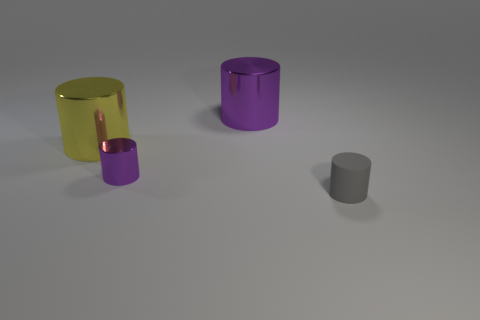Are there any purple shiny cylinders that have the same size as the yellow object?
Give a very brief answer. Yes. What size is the gray rubber thing?
Provide a succinct answer. Small. Are there an equal number of tiny matte cylinders that are behind the rubber cylinder and purple cylinders?
Your answer should be compact. No. How many other things are there of the same color as the matte thing?
Your response must be concise. 0. What color is the cylinder that is both behind the small purple cylinder and right of the big yellow metallic cylinder?
Provide a short and direct response. Purple. There is a metal cylinder that is behind the large metal cylinder in front of the large shiny object behind the yellow metallic object; how big is it?
Make the answer very short. Large. How many things are objects left of the small gray rubber thing or cylinders that are behind the gray rubber cylinder?
Keep it short and to the point. 3. The yellow shiny object has what shape?
Ensure brevity in your answer.  Cylinder. What number of other things are there of the same material as the tiny gray thing
Give a very brief answer. 0. What is the size of the other yellow object that is the same shape as the small matte object?
Give a very brief answer. Large. 